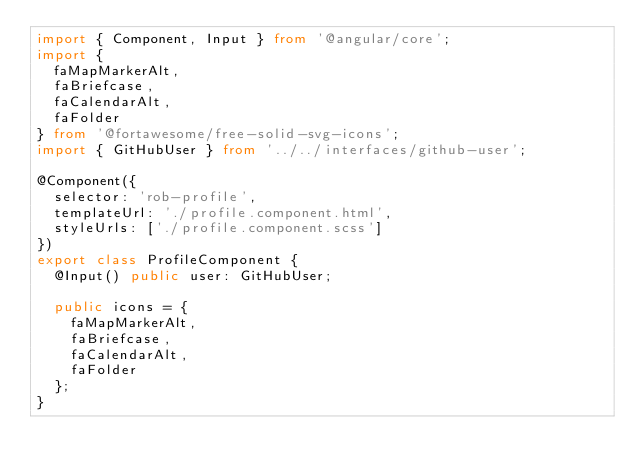Convert code to text. <code><loc_0><loc_0><loc_500><loc_500><_TypeScript_>import { Component, Input } from '@angular/core';
import {
  faMapMarkerAlt,
  faBriefcase,
  faCalendarAlt,
  faFolder
} from '@fortawesome/free-solid-svg-icons';
import { GitHubUser } from '../../interfaces/github-user';

@Component({
  selector: 'rob-profile',
  templateUrl: './profile.component.html',
  styleUrls: ['./profile.component.scss']
})
export class ProfileComponent {
  @Input() public user: GitHubUser;

  public icons = {
    faMapMarkerAlt,
    faBriefcase,
    faCalendarAlt,
    faFolder
  };
}
</code> 